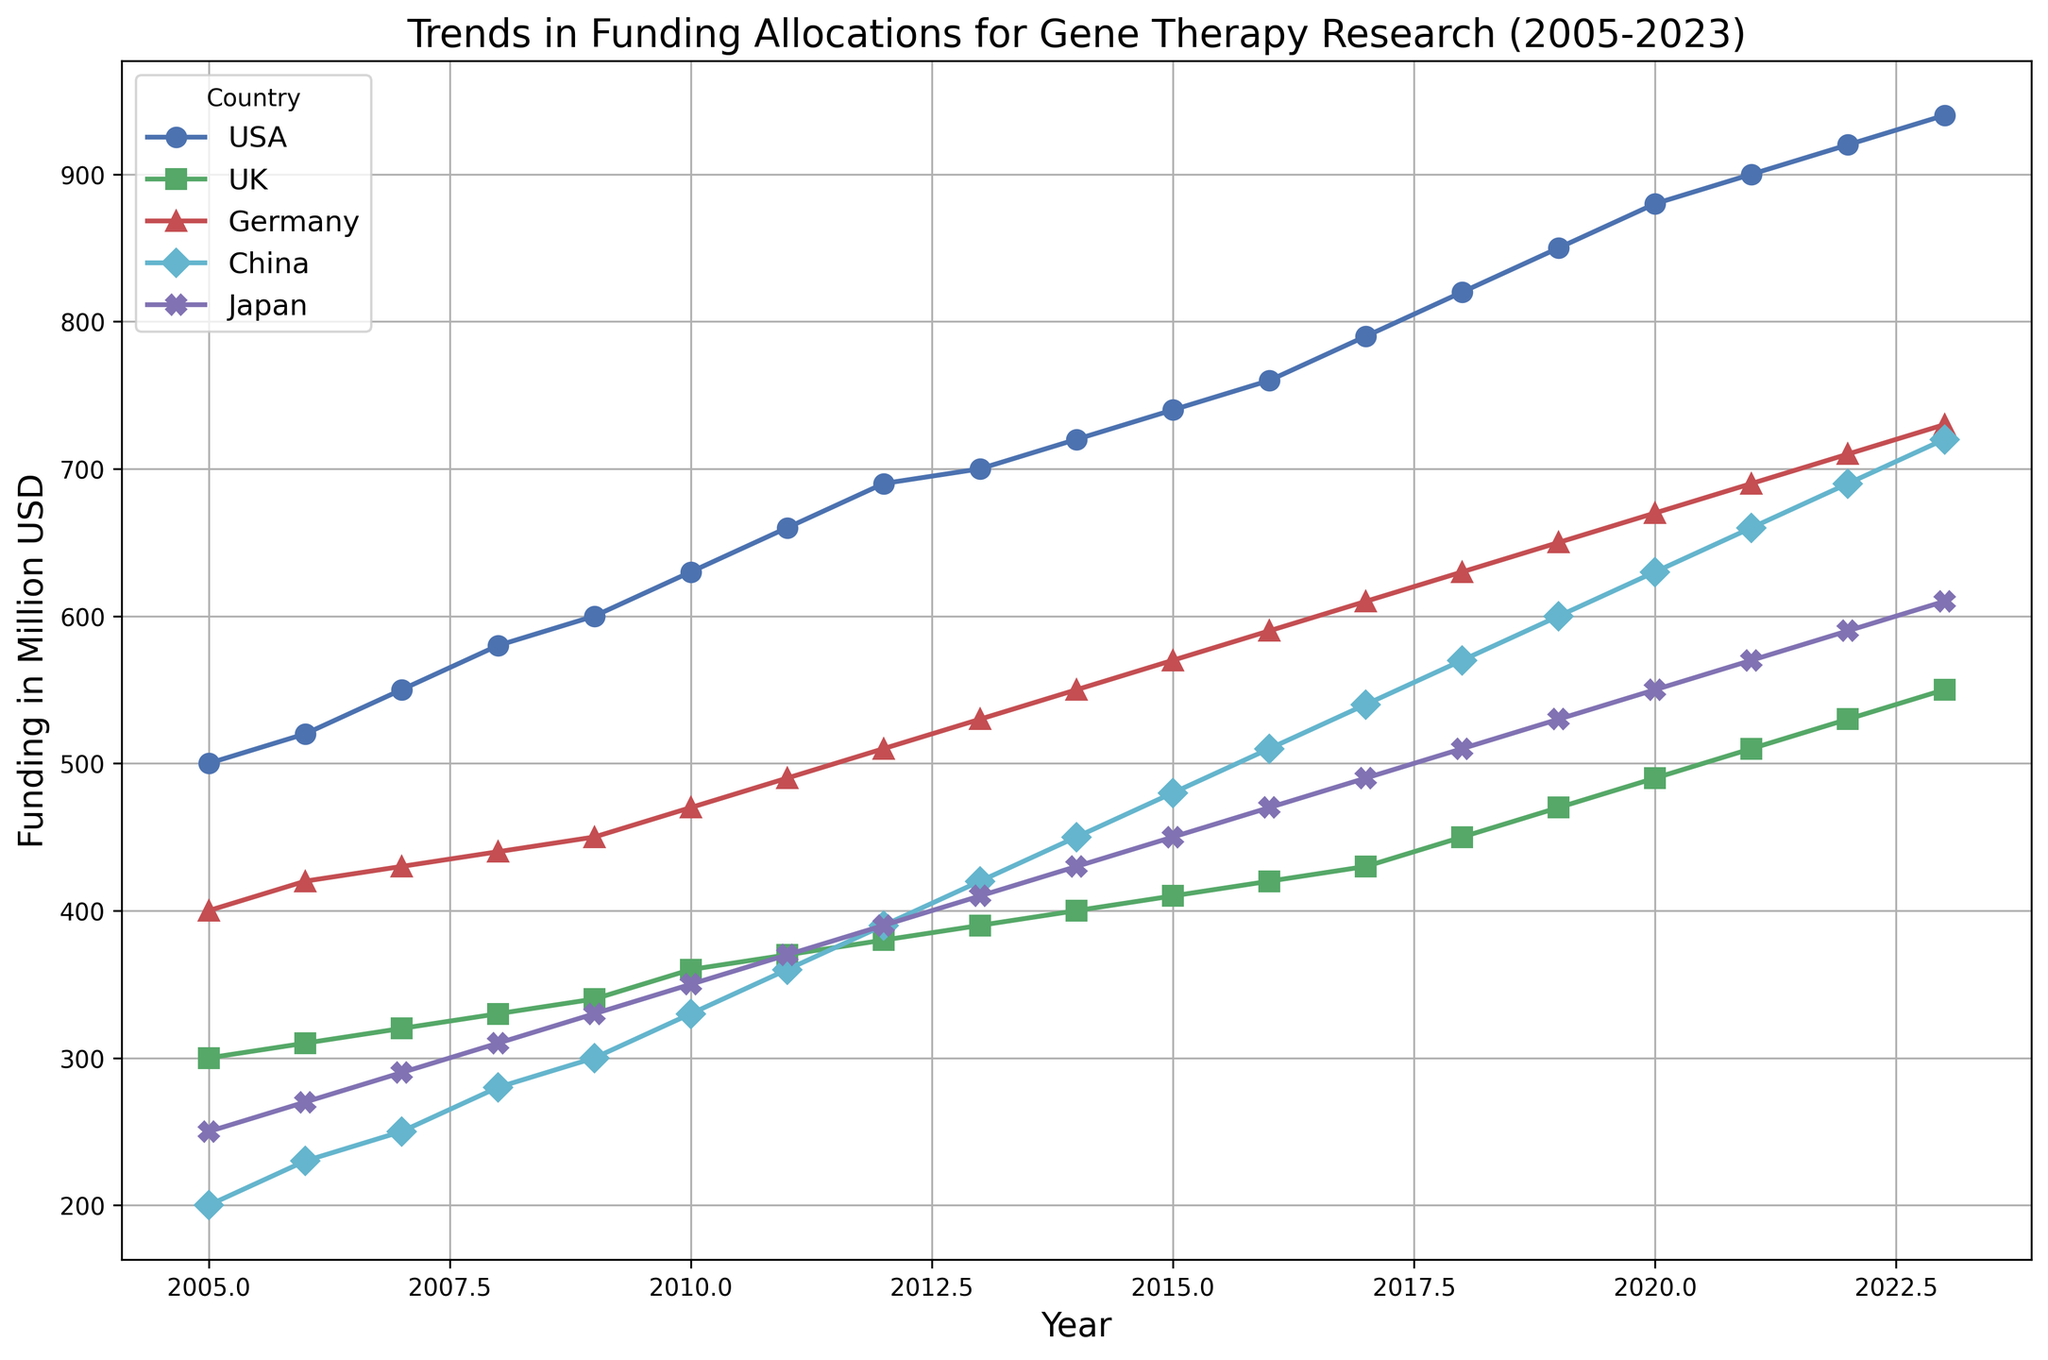Which country has the highest funding allocation in 2023? Look at the endpoints of the lines for each country in 2023. The USA has the highest value at 940 million USD.
Answer: USA How much did the funding for gene therapy research in Japan increase from 2005 to 2023? Find the difference between the funding values for Japan in 2023 and 2005 from the chart. (610 - 250 = 360)
Answer: 360 million USD Which two countries have the closest funding levels in 2023? Compare the endpoints of the lines for all countries in 2023. The funding levels for Germany (730 million USD) and China (720 million USD) are closest.
Answer: Germany and China How does the funding growth rate of the UK compare to that of the USA over the period 2005 to 2023? Calculate the increase for each country from 2005 to 2023. UK: (550-300 = 250) and USA: (940-500 = 440). The UK's funding grew by 250 million USD while the USA's grew by 440 million USD, which means the USA's growth rate is higher.
Answer: USA's growth rate is higher What is the average funding allocation for Germany from 2005 to 2023? Add up all the funding values for Germany from 2005 to 2023 and divide by the number of years. (400 + 420 + 430 + ... + 710 + 730) / 19
Answer: Approximately 540 million USD In which year did China first surpass 500 million USD in funding? Look at the point in the China line where the funding value first exceeds 500 million USD. This occurs in 2016.
Answer: 2016 Which country had the most consistent funding growth each year from 2005 to 2023? Examine the smoothness and linearity of the lines. The USA shows the most consistent linear growth without any noticeable jumps or drops.
Answer: USA By how much did the funding for gene therapy research in China increase between 2010 and 2020? Subtract the value in 2010 from the value in 2020 for China. (630-330 = 300)
Answer: 300 million USD What is the funding difference between the UK and Japan in 2023? Subtract Japan's 2023 funding value from the UK's 2023 funding value. (550 - 610) = -60. Japan has 60 million USD more funding than the UK in 2023.
Answer: 60 million USD (Japan more) When did Germany first reach 500 million USD in funding? Locate the point on Germany's line that first hits 500 million USD, which happens in 2012.
Answer: 2012 